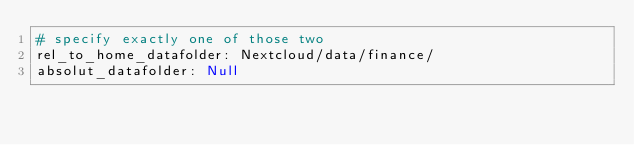Convert code to text. <code><loc_0><loc_0><loc_500><loc_500><_YAML_># specify exactly one of those two
rel_to_home_datafolder: Nextcloud/data/finance/
absolut_datafolder: Null
</code> 